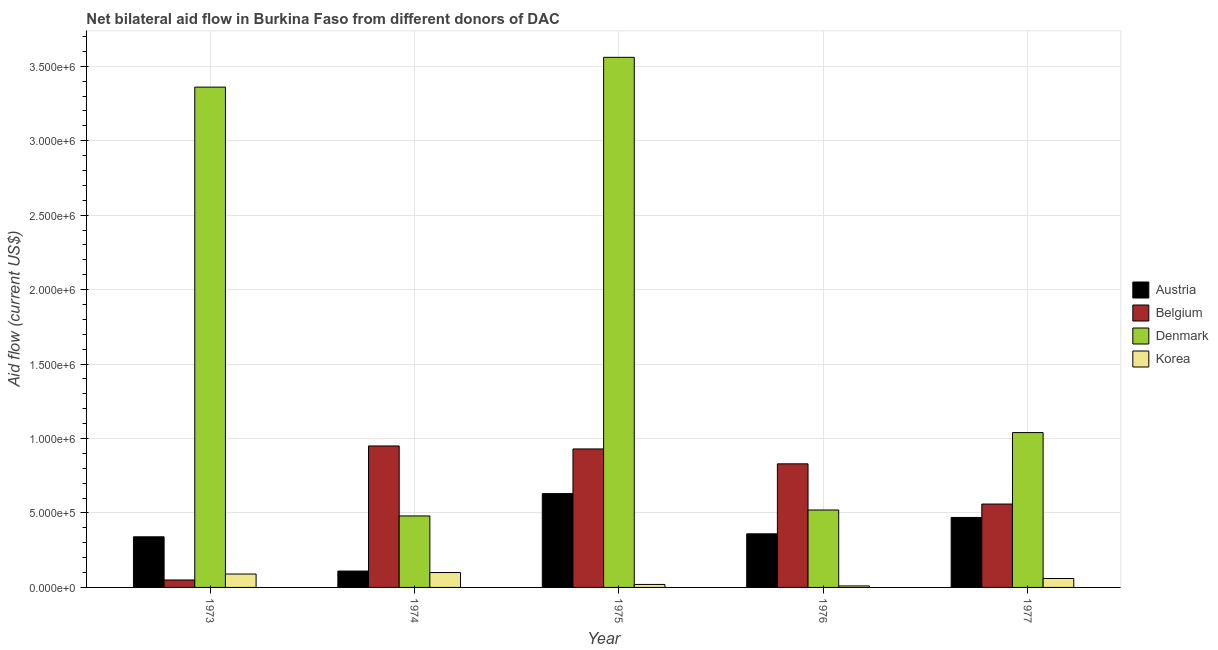How many different coloured bars are there?
Ensure brevity in your answer.  4. Are the number of bars per tick equal to the number of legend labels?
Provide a short and direct response. Yes. How many bars are there on the 3rd tick from the left?
Your answer should be compact. 4. How many bars are there on the 2nd tick from the right?
Offer a terse response. 4. What is the label of the 2nd group of bars from the left?
Keep it short and to the point. 1974. In how many cases, is the number of bars for a given year not equal to the number of legend labels?
Give a very brief answer. 0. What is the amount of aid given by belgium in 1977?
Your answer should be compact. 5.60e+05. Across all years, what is the maximum amount of aid given by denmark?
Ensure brevity in your answer.  3.56e+06. Across all years, what is the minimum amount of aid given by belgium?
Your response must be concise. 5.00e+04. In which year was the amount of aid given by denmark maximum?
Your answer should be compact. 1975. In which year was the amount of aid given by korea minimum?
Keep it short and to the point. 1976. What is the total amount of aid given by korea in the graph?
Offer a terse response. 2.80e+05. What is the difference between the amount of aid given by austria in 1974 and that in 1975?
Ensure brevity in your answer.  -5.20e+05. What is the difference between the amount of aid given by denmark in 1977 and the amount of aid given by korea in 1975?
Your answer should be compact. -2.52e+06. What is the average amount of aid given by austria per year?
Give a very brief answer. 3.82e+05. What is the ratio of the amount of aid given by austria in 1974 to that in 1977?
Make the answer very short. 0.23. Is the amount of aid given by denmark in 1975 less than that in 1977?
Keep it short and to the point. No. Is the difference between the amount of aid given by korea in 1973 and 1977 greater than the difference between the amount of aid given by belgium in 1973 and 1977?
Give a very brief answer. No. What is the difference between the highest and the second highest amount of aid given by austria?
Make the answer very short. 1.60e+05. What is the difference between the highest and the lowest amount of aid given by belgium?
Make the answer very short. 9.00e+05. Is the sum of the amount of aid given by belgium in 1975 and 1976 greater than the maximum amount of aid given by korea across all years?
Give a very brief answer. Yes. What does the 3rd bar from the left in 1973 represents?
Make the answer very short. Denmark. What does the 4th bar from the right in 1977 represents?
Offer a terse response. Austria. What is the difference between two consecutive major ticks on the Y-axis?
Make the answer very short. 5.00e+05. Does the graph contain grids?
Offer a terse response. Yes. How are the legend labels stacked?
Provide a succinct answer. Vertical. What is the title of the graph?
Make the answer very short. Net bilateral aid flow in Burkina Faso from different donors of DAC. Does "Labor Taxes" appear as one of the legend labels in the graph?
Your answer should be very brief. No. What is the label or title of the X-axis?
Provide a short and direct response. Year. What is the Aid flow (current US$) of Belgium in 1973?
Ensure brevity in your answer.  5.00e+04. What is the Aid flow (current US$) in Denmark in 1973?
Ensure brevity in your answer.  3.36e+06. What is the Aid flow (current US$) of Korea in 1973?
Your response must be concise. 9.00e+04. What is the Aid flow (current US$) of Belgium in 1974?
Offer a very short reply. 9.50e+05. What is the Aid flow (current US$) in Austria in 1975?
Your response must be concise. 6.30e+05. What is the Aid flow (current US$) in Belgium in 1975?
Your response must be concise. 9.30e+05. What is the Aid flow (current US$) of Denmark in 1975?
Offer a very short reply. 3.56e+06. What is the Aid flow (current US$) of Korea in 1975?
Your answer should be very brief. 2.00e+04. What is the Aid flow (current US$) of Austria in 1976?
Your answer should be very brief. 3.60e+05. What is the Aid flow (current US$) of Belgium in 1976?
Ensure brevity in your answer.  8.30e+05. What is the Aid flow (current US$) in Denmark in 1976?
Give a very brief answer. 5.20e+05. What is the Aid flow (current US$) in Korea in 1976?
Provide a short and direct response. 10000. What is the Aid flow (current US$) in Austria in 1977?
Make the answer very short. 4.70e+05. What is the Aid flow (current US$) in Belgium in 1977?
Provide a short and direct response. 5.60e+05. What is the Aid flow (current US$) of Denmark in 1977?
Your answer should be compact. 1.04e+06. What is the Aid flow (current US$) of Korea in 1977?
Provide a succinct answer. 6.00e+04. Across all years, what is the maximum Aid flow (current US$) in Austria?
Provide a short and direct response. 6.30e+05. Across all years, what is the maximum Aid flow (current US$) of Belgium?
Make the answer very short. 9.50e+05. Across all years, what is the maximum Aid flow (current US$) of Denmark?
Offer a terse response. 3.56e+06. Across all years, what is the maximum Aid flow (current US$) of Korea?
Your answer should be compact. 1.00e+05. Across all years, what is the minimum Aid flow (current US$) of Austria?
Ensure brevity in your answer.  1.10e+05. Across all years, what is the minimum Aid flow (current US$) of Belgium?
Your answer should be very brief. 5.00e+04. Across all years, what is the minimum Aid flow (current US$) in Denmark?
Offer a very short reply. 4.80e+05. Across all years, what is the minimum Aid flow (current US$) in Korea?
Your response must be concise. 10000. What is the total Aid flow (current US$) in Austria in the graph?
Ensure brevity in your answer.  1.91e+06. What is the total Aid flow (current US$) in Belgium in the graph?
Offer a terse response. 3.32e+06. What is the total Aid flow (current US$) of Denmark in the graph?
Make the answer very short. 8.96e+06. What is the total Aid flow (current US$) of Korea in the graph?
Offer a very short reply. 2.80e+05. What is the difference between the Aid flow (current US$) in Austria in 1973 and that in 1974?
Provide a succinct answer. 2.30e+05. What is the difference between the Aid flow (current US$) of Belgium in 1973 and that in 1974?
Make the answer very short. -9.00e+05. What is the difference between the Aid flow (current US$) of Denmark in 1973 and that in 1974?
Your response must be concise. 2.88e+06. What is the difference between the Aid flow (current US$) of Korea in 1973 and that in 1974?
Ensure brevity in your answer.  -10000. What is the difference between the Aid flow (current US$) in Austria in 1973 and that in 1975?
Your response must be concise. -2.90e+05. What is the difference between the Aid flow (current US$) of Belgium in 1973 and that in 1975?
Offer a very short reply. -8.80e+05. What is the difference between the Aid flow (current US$) in Denmark in 1973 and that in 1975?
Your response must be concise. -2.00e+05. What is the difference between the Aid flow (current US$) in Korea in 1973 and that in 1975?
Offer a terse response. 7.00e+04. What is the difference between the Aid flow (current US$) of Belgium in 1973 and that in 1976?
Offer a very short reply. -7.80e+05. What is the difference between the Aid flow (current US$) in Denmark in 1973 and that in 1976?
Give a very brief answer. 2.84e+06. What is the difference between the Aid flow (current US$) of Belgium in 1973 and that in 1977?
Your answer should be compact. -5.10e+05. What is the difference between the Aid flow (current US$) in Denmark in 1973 and that in 1977?
Your answer should be very brief. 2.32e+06. What is the difference between the Aid flow (current US$) of Korea in 1973 and that in 1977?
Your response must be concise. 3.00e+04. What is the difference between the Aid flow (current US$) of Austria in 1974 and that in 1975?
Ensure brevity in your answer.  -5.20e+05. What is the difference between the Aid flow (current US$) of Belgium in 1974 and that in 1975?
Make the answer very short. 2.00e+04. What is the difference between the Aid flow (current US$) in Denmark in 1974 and that in 1975?
Offer a very short reply. -3.08e+06. What is the difference between the Aid flow (current US$) in Korea in 1974 and that in 1975?
Make the answer very short. 8.00e+04. What is the difference between the Aid flow (current US$) of Austria in 1974 and that in 1976?
Offer a terse response. -2.50e+05. What is the difference between the Aid flow (current US$) of Belgium in 1974 and that in 1976?
Ensure brevity in your answer.  1.20e+05. What is the difference between the Aid flow (current US$) in Korea in 1974 and that in 1976?
Provide a short and direct response. 9.00e+04. What is the difference between the Aid flow (current US$) of Austria in 1974 and that in 1977?
Keep it short and to the point. -3.60e+05. What is the difference between the Aid flow (current US$) in Denmark in 1974 and that in 1977?
Provide a succinct answer. -5.60e+05. What is the difference between the Aid flow (current US$) of Belgium in 1975 and that in 1976?
Provide a succinct answer. 1.00e+05. What is the difference between the Aid flow (current US$) of Denmark in 1975 and that in 1976?
Provide a succinct answer. 3.04e+06. What is the difference between the Aid flow (current US$) of Belgium in 1975 and that in 1977?
Keep it short and to the point. 3.70e+05. What is the difference between the Aid flow (current US$) in Denmark in 1975 and that in 1977?
Your answer should be compact. 2.52e+06. What is the difference between the Aid flow (current US$) in Belgium in 1976 and that in 1977?
Make the answer very short. 2.70e+05. What is the difference between the Aid flow (current US$) in Denmark in 1976 and that in 1977?
Your answer should be compact. -5.20e+05. What is the difference between the Aid flow (current US$) in Korea in 1976 and that in 1977?
Ensure brevity in your answer.  -5.00e+04. What is the difference between the Aid flow (current US$) in Austria in 1973 and the Aid flow (current US$) in Belgium in 1974?
Provide a short and direct response. -6.10e+05. What is the difference between the Aid flow (current US$) of Austria in 1973 and the Aid flow (current US$) of Korea in 1974?
Offer a very short reply. 2.40e+05. What is the difference between the Aid flow (current US$) of Belgium in 1973 and the Aid flow (current US$) of Denmark in 1974?
Your answer should be very brief. -4.30e+05. What is the difference between the Aid flow (current US$) in Denmark in 1973 and the Aid flow (current US$) in Korea in 1974?
Provide a short and direct response. 3.26e+06. What is the difference between the Aid flow (current US$) of Austria in 1973 and the Aid flow (current US$) of Belgium in 1975?
Keep it short and to the point. -5.90e+05. What is the difference between the Aid flow (current US$) in Austria in 1973 and the Aid flow (current US$) in Denmark in 1975?
Give a very brief answer. -3.22e+06. What is the difference between the Aid flow (current US$) in Austria in 1973 and the Aid flow (current US$) in Korea in 1975?
Provide a short and direct response. 3.20e+05. What is the difference between the Aid flow (current US$) of Belgium in 1973 and the Aid flow (current US$) of Denmark in 1975?
Offer a very short reply. -3.51e+06. What is the difference between the Aid flow (current US$) in Denmark in 1973 and the Aid flow (current US$) in Korea in 1975?
Make the answer very short. 3.34e+06. What is the difference between the Aid flow (current US$) in Austria in 1973 and the Aid flow (current US$) in Belgium in 1976?
Give a very brief answer. -4.90e+05. What is the difference between the Aid flow (current US$) in Austria in 1973 and the Aid flow (current US$) in Korea in 1976?
Your response must be concise. 3.30e+05. What is the difference between the Aid flow (current US$) in Belgium in 1973 and the Aid flow (current US$) in Denmark in 1976?
Make the answer very short. -4.70e+05. What is the difference between the Aid flow (current US$) of Denmark in 1973 and the Aid flow (current US$) of Korea in 1976?
Give a very brief answer. 3.35e+06. What is the difference between the Aid flow (current US$) in Austria in 1973 and the Aid flow (current US$) in Denmark in 1977?
Keep it short and to the point. -7.00e+05. What is the difference between the Aid flow (current US$) of Belgium in 1973 and the Aid flow (current US$) of Denmark in 1977?
Ensure brevity in your answer.  -9.90e+05. What is the difference between the Aid flow (current US$) in Belgium in 1973 and the Aid flow (current US$) in Korea in 1977?
Your response must be concise. -10000. What is the difference between the Aid flow (current US$) of Denmark in 1973 and the Aid flow (current US$) of Korea in 1977?
Your answer should be very brief. 3.30e+06. What is the difference between the Aid flow (current US$) in Austria in 1974 and the Aid flow (current US$) in Belgium in 1975?
Offer a terse response. -8.20e+05. What is the difference between the Aid flow (current US$) in Austria in 1974 and the Aid flow (current US$) in Denmark in 1975?
Your answer should be compact. -3.45e+06. What is the difference between the Aid flow (current US$) of Austria in 1974 and the Aid flow (current US$) of Korea in 1975?
Your answer should be very brief. 9.00e+04. What is the difference between the Aid flow (current US$) in Belgium in 1974 and the Aid flow (current US$) in Denmark in 1975?
Keep it short and to the point. -2.61e+06. What is the difference between the Aid flow (current US$) of Belgium in 1974 and the Aid flow (current US$) of Korea in 1975?
Your answer should be very brief. 9.30e+05. What is the difference between the Aid flow (current US$) in Austria in 1974 and the Aid flow (current US$) in Belgium in 1976?
Provide a succinct answer. -7.20e+05. What is the difference between the Aid flow (current US$) in Austria in 1974 and the Aid flow (current US$) in Denmark in 1976?
Offer a very short reply. -4.10e+05. What is the difference between the Aid flow (current US$) of Belgium in 1974 and the Aid flow (current US$) of Korea in 1976?
Your response must be concise. 9.40e+05. What is the difference between the Aid flow (current US$) in Austria in 1974 and the Aid flow (current US$) in Belgium in 1977?
Make the answer very short. -4.50e+05. What is the difference between the Aid flow (current US$) of Austria in 1974 and the Aid flow (current US$) of Denmark in 1977?
Offer a terse response. -9.30e+05. What is the difference between the Aid flow (current US$) of Austria in 1974 and the Aid flow (current US$) of Korea in 1977?
Ensure brevity in your answer.  5.00e+04. What is the difference between the Aid flow (current US$) in Belgium in 1974 and the Aid flow (current US$) in Korea in 1977?
Offer a terse response. 8.90e+05. What is the difference between the Aid flow (current US$) of Austria in 1975 and the Aid flow (current US$) of Belgium in 1976?
Provide a short and direct response. -2.00e+05. What is the difference between the Aid flow (current US$) in Austria in 1975 and the Aid flow (current US$) in Korea in 1976?
Provide a short and direct response. 6.20e+05. What is the difference between the Aid flow (current US$) in Belgium in 1975 and the Aid flow (current US$) in Korea in 1976?
Your answer should be compact. 9.20e+05. What is the difference between the Aid flow (current US$) of Denmark in 1975 and the Aid flow (current US$) of Korea in 1976?
Ensure brevity in your answer.  3.55e+06. What is the difference between the Aid flow (current US$) of Austria in 1975 and the Aid flow (current US$) of Belgium in 1977?
Provide a succinct answer. 7.00e+04. What is the difference between the Aid flow (current US$) of Austria in 1975 and the Aid flow (current US$) of Denmark in 1977?
Offer a terse response. -4.10e+05. What is the difference between the Aid flow (current US$) in Austria in 1975 and the Aid flow (current US$) in Korea in 1977?
Ensure brevity in your answer.  5.70e+05. What is the difference between the Aid flow (current US$) of Belgium in 1975 and the Aid flow (current US$) of Korea in 1977?
Ensure brevity in your answer.  8.70e+05. What is the difference between the Aid flow (current US$) of Denmark in 1975 and the Aid flow (current US$) of Korea in 1977?
Provide a short and direct response. 3.50e+06. What is the difference between the Aid flow (current US$) in Austria in 1976 and the Aid flow (current US$) in Belgium in 1977?
Your answer should be compact. -2.00e+05. What is the difference between the Aid flow (current US$) in Austria in 1976 and the Aid flow (current US$) in Denmark in 1977?
Your response must be concise. -6.80e+05. What is the difference between the Aid flow (current US$) of Austria in 1976 and the Aid flow (current US$) of Korea in 1977?
Ensure brevity in your answer.  3.00e+05. What is the difference between the Aid flow (current US$) in Belgium in 1976 and the Aid flow (current US$) in Korea in 1977?
Offer a very short reply. 7.70e+05. What is the difference between the Aid flow (current US$) of Denmark in 1976 and the Aid flow (current US$) of Korea in 1977?
Offer a very short reply. 4.60e+05. What is the average Aid flow (current US$) in Austria per year?
Provide a short and direct response. 3.82e+05. What is the average Aid flow (current US$) of Belgium per year?
Give a very brief answer. 6.64e+05. What is the average Aid flow (current US$) of Denmark per year?
Give a very brief answer. 1.79e+06. What is the average Aid flow (current US$) of Korea per year?
Offer a very short reply. 5.60e+04. In the year 1973, what is the difference between the Aid flow (current US$) of Austria and Aid flow (current US$) of Belgium?
Provide a short and direct response. 2.90e+05. In the year 1973, what is the difference between the Aid flow (current US$) in Austria and Aid flow (current US$) in Denmark?
Ensure brevity in your answer.  -3.02e+06. In the year 1973, what is the difference between the Aid flow (current US$) in Belgium and Aid flow (current US$) in Denmark?
Ensure brevity in your answer.  -3.31e+06. In the year 1973, what is the difference between the Aid flow (current US$) in Belgium and Aid flow (current US$) in Korea?
Give a very brief answer. -4.00e+04. In the year 1973, what is the difference between the Aid flow (current US$) in Denmark and Aid flow (current US$) in Korea?
Offer a terse response. 3.27e+06. In the year 1974, what is the difference between the Aid flow (current US$) of Austria and Aid flow (current US$) of Belgium?
Make the answer very short. -8.40e+05. In the year 1974, what is the difference between the Aid flow (current US$) in Austria and Aid flow (current US$) in Denmark?
Give a very brief answer. -3.70e+05. In the year 1974, what is the difference between the Aid flow (current US$) of Belgium and Aid flow (current US$) of Denmark?
Your answer should be very brief. 4.70e+05. In the year 1974, what is the difference between the Aid flow (current US$) of Belgium and Aid flow (current US$) of Korea?
Your answer should be compact. 8.50e+05. In the year 1974, what is the difference between the Aid flow (current US$) of Denmark and Aid flow (current US$) of Korea?
Your response must be concise. 3.80e+05. In the year 1975, what is the difference between the Aid flow (current US$) in Austria and Aid flow (current US$) in Belgium?
Provide a succinct answer. -3.00e+05. In the year 1975, what is the difference between the Aid flow (current US$) in Austria and Aid flow (current US$) in Denmark?
Make the answer very short. -2.93e+06. In the year 1975, what is the difference between the Aid flow (current US$) of Belgium and Aid flow (current US$) of Denmark?
Your response must be concise. -2.63e+06. In the year 1975, what is the difference between the Aid flow (current US$) in Belgium and Aid flow (current US$) in Korea?
Make the answer very short. 9.10e+05. In the year 1975, what is the difference between the Aid flow (current US$) in Denmark and Aid flow (current US$) in Korea?
Provide a succinct answer. 3.54e+06. In the year 1976, what is the difference between the Aid flow (current US$) in Austria and Aid flow (current US$) in Belgium?
Provide a short and direct response. -4.70e+05. In the year 1976, what is the difference between the Aid flow (current US$) of Austria and Aid flow (current US$) of Denmark?
Provide a succinct answer. -1.60e+05. In the year 1976, what is the difference between the Aid flow (current US$) in Austria and Aid flow (current US$) in Korea?
Offer a very short reply. 3.50e+05. In the year 1976, what is the difference between the Aid flow (current US$) in Belgium and Aid flow (current US$) in Korea?
Offer a terse response. 8.20e+05. In the year 1976, what is the difference between the Aid flow (current US$) in Denmark and Aid flow (current US$) in Korea?
Give a very brief answer. 5.10e+05. In the year 1977, what is the difference between the Aid flow (current US$) of Austria and Aid flow (current US$) of Belgium?
Keep it short and to the point. -9.00e+04. In the year 1977, what is the difference between the Aid flow (current US$) in Austria and Aid flow (current US$) in Denmark?
Give a very brief answer. -5.70e+05. In the year 1977, what is the difference between the Aid flow (current US$) in Belgium and Aid flow (current US$) in Denmark?
Give a very brief answer. -4.80e+05. In the year 1977, what is the difference between the Aid flow (current US$) of Belgium and Aid flow (current US$) of Korea?
Ensure brevity in your answer.  5.00e+05. In the year 1977, what is the difference between the Aid flow (current US$) in Denmark and Aid flow (current US$) in Korea?
Ensure brevity in your answer.  9.80e+05. What is the ratio of the Aid flow (current US$) of Austria in 1973 to that in 1974?
Provide a succinct answer. 3.09. What is the ratio of the Aid flow (current US$) in Belgium in 1973 to that in 1974?
Make the answer very short. 0.05. What is the ratio of the Aid flow (current US$) of Denmark in 1973 to that in 1974?
Provide a succinct answer. 7. What is the ratio of the Aid flow (current US$) in Korea in 1973 to that in 1974?
Make the answer very short. 0.9. What is the ratio of the Aid flow (current US$) in Austria in 1973 to that in 1975?
Give a very brief answer. 0.54. What is the ratio of the Aid flow (current US$) in Belgium in 1973 to that in 1975?
Make the answer very short. 0.05. What is the ratio of the Aid flow (current US$) of Denmark in 1973 to that in 1975?
Provide a succinct answer. 0.94. What is the ratio of the Aid flow (current US$) in Korea in 1973 to that in 1975?
Offer a very short reply. 4.5. What is the ratio of the Aid flow (current US$) in Austria in 1973 to that in 1976?
Provide a succinct answer. 0.94. What is the ratio of the Aid flow (current US$) in Belgium in 1973 to that in 1976?
Give a very brief answer. 0.06. What is the ratio of the Aid flow (current US$) of Denmark in 1973 to that in 1976?
Ensure brevity in your answer.  6.46. What is the ratio of the Aid flow (current US$) of Austria in 1973 to that in 1977?
Your answer should be very brief. 0.72. What is the ratio of the Aid flow (current US$) of Belgium in 1973 to that in 1977?
Make the answer very short. 0.09. What is the ratio of the Aid flow (current US$) in Denmark in 1973 to that in 1977?
Your response must be concise. 3.23. What is the ratio of the Aid flow (current US$) in Austria in 1974 to that in 1975?
Offer a terse response. 0.17. What is the ratio of the Aid flow (current US$) of Belgium in 1974 to that in 1975?
Your answer should be very brief. 1.02. What is the ratio of the Aid flow (current US$) of Denmark in 1974 to that in 1975?
Give a very brief answer. 0.13. What is the ratio of the Aid flow (current US$) in Korea in 1974 to that in 1975?
Offer a very short reply. 5. What is the ratio of the Aid flow (current US$) in Austria in 1974 to that in 1976?
Provide a short and direct response. 0.31. What is the ratio of the Aid flow (current US$) of Belgium in 1974 to that in 1976?
Offer a very short reply. 1.14. What is the ratio of the Aid flow (current US$) of Austria in 1974 to that in 1977?
Your response must be concise. 0.23. What is the ratio of the Aid flow (current US$) in Belgium in 1974 to that in 1977?
Provide a short and direct response. 1.7. What is the ratio of the Aid flow (current US$) in Denmark in 1974 to that in 1977?
Provide a succinct answer. 0.46. What is the ratio of the Aid flow (current US$) in Korea in 1974 to that in 1977?
Ensure brevity in your answer.  1.67. What is the ratio of the Aid flow (current US$) in Belgium in 1975 to that in 1976?
Your answer should be compact. 1.12. What is the ratio of the Aid flow (current US$) in Denmark in 1975 to that in 1976?
Offer a terse response. 6.85. What is the ratio of the Aid flow (current US$) of Austria in 1975 to that in 1977?
Keep it short and to the point. 1.34. What is the ratio of the Aid flow (current US$) in Belgium in 1975 to that in 1977?
Ensure brevity in your answer.  1.66. What is the ratio of the Aid flow (current US$) of Denmark in 1975 to that in 1977?
Keep it short and to the point. 3.42. What is the ratio of the Aid flow (current US$) in Austria in 1976 to that in 1977?
Keep it short and to the point. 0.77. What is the ratio of the Aid flow (current US$) in Belgium in 1976 to that in 1977?
Offer a terse response. 1.48. What is the difference between the highest and the second highest Aid flow (current US$) in Austria?
Your response must be concise. 1.60e+05. What is the difference between the highest and the second highest Aid flow (current US$) of Korea?
Provide a succinct answer. 10000. What is the difference between the highest and the lowest Aid flow (current US$) of Austria?
Your answer should be compact. 5.20e+05. What is the difference between the highest and the lowest Aid flow (current US$) in Denmark?
Your response must be concise. 3.08e+06. What is the difference between the highest and the lowest Aid flow (current US$) of Korea?
Your response must be concise. 9.00e+04. 